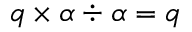<formula> <loc_0><loc_0><loc_500><loc_500>q \times \alpha \div \alpha = q</formula> 